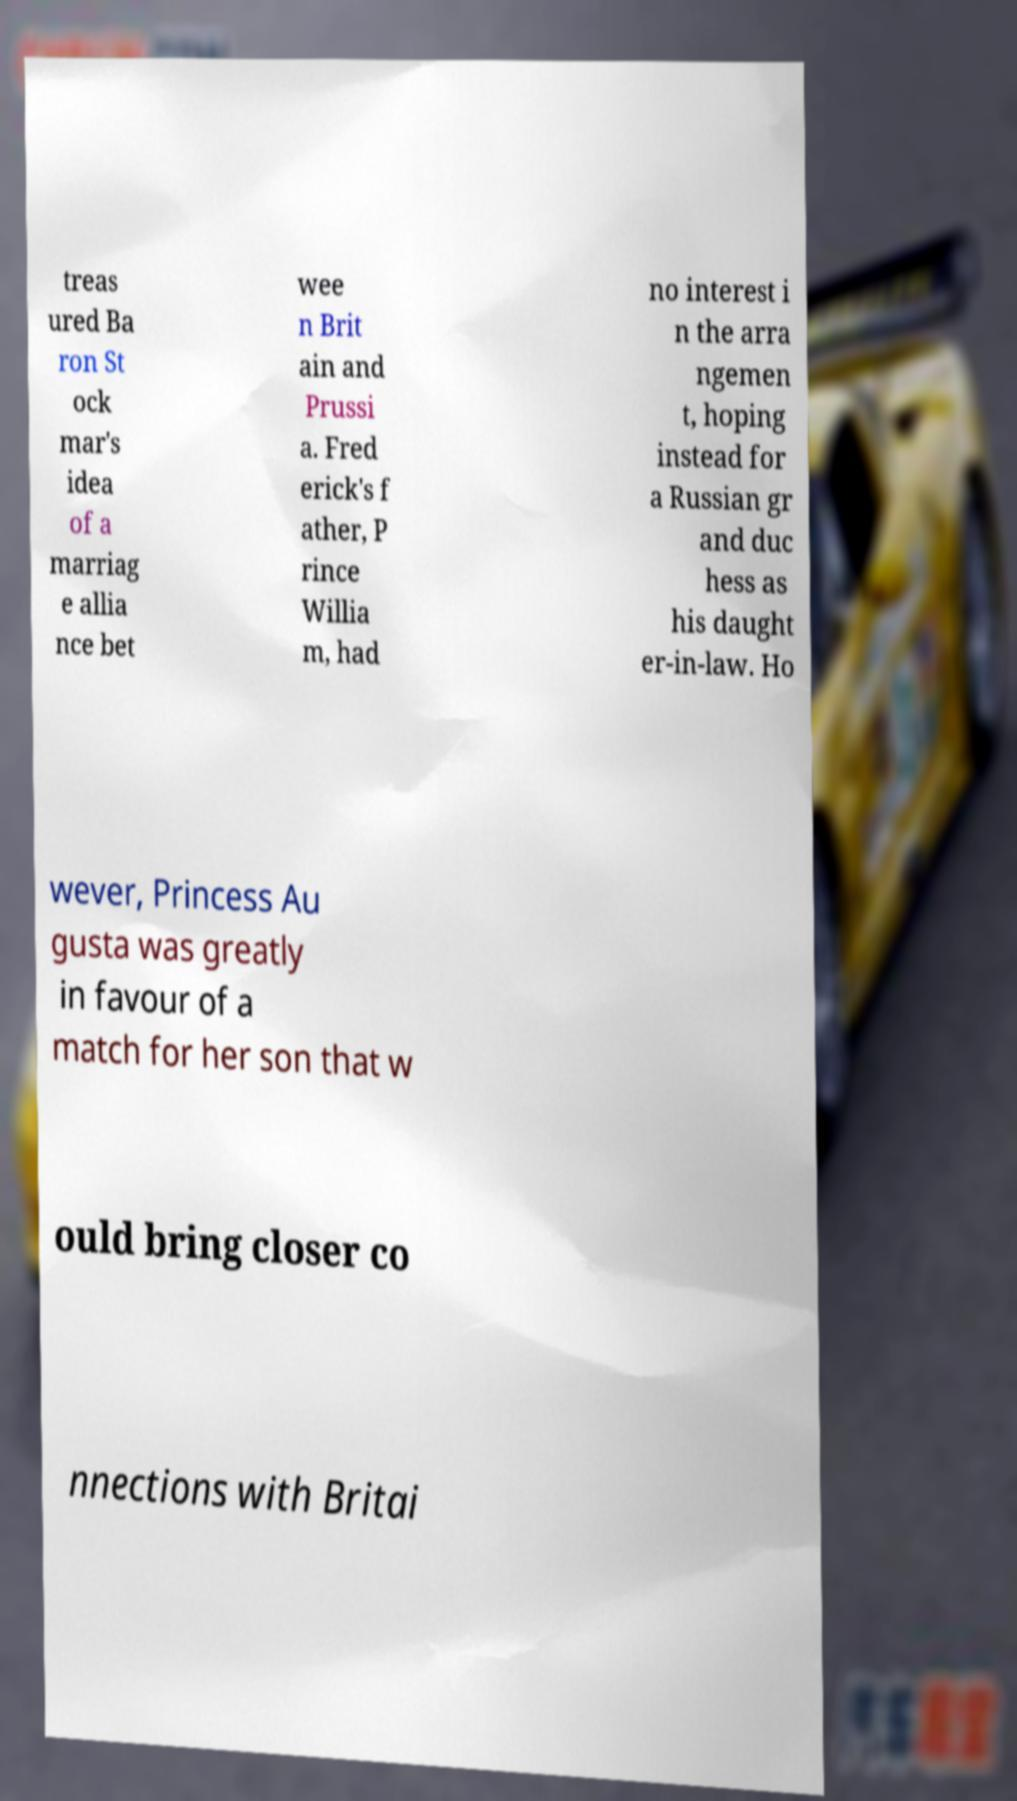Please read and relay the text visible in this image. What does it say? treas ured Ba ron St ock mar's idea of a marriag e allia nce bet wee n Brit ain and Prussi a. Fred erick's f ather, P rince Willia m, had no interest i n the arra ngemen t, hoping instead for a Russian gr and duc hess as his daught er-in-law. Ho wever, Princess Au gusta was greatly in favour of a match for her son that w ould bring closer co nnections with Britai 